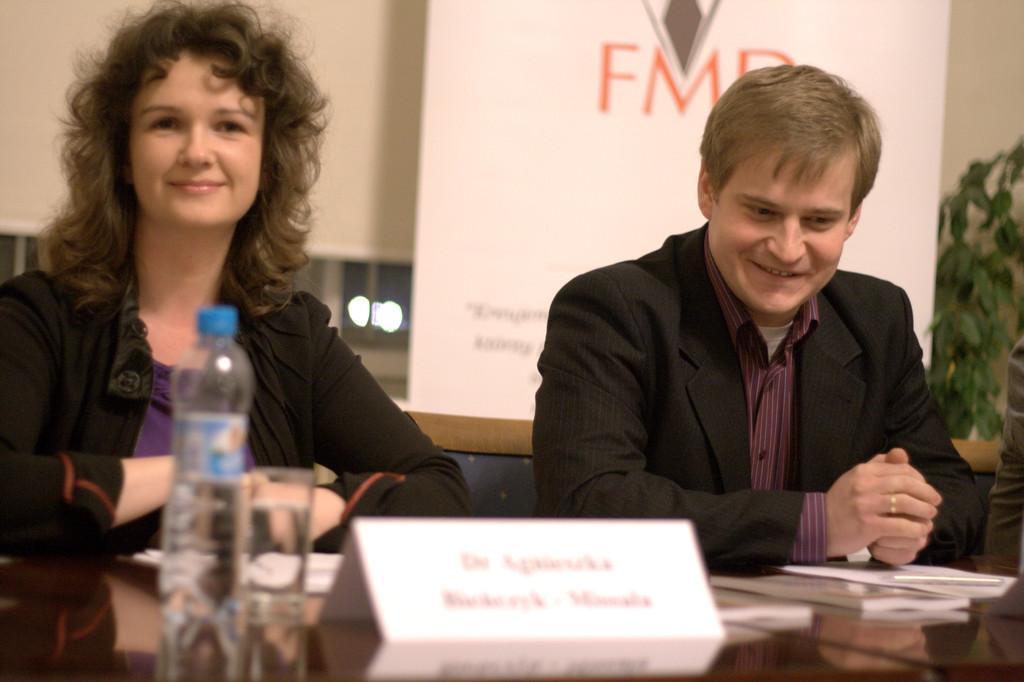Could you give a brief overview of what you see in this image? In this image we can see two persons. In the background of the image there is a wall, plant, logo and other objects. At the bottom of the image there is the bottle, glass, name board, books and other objects on the surface. 